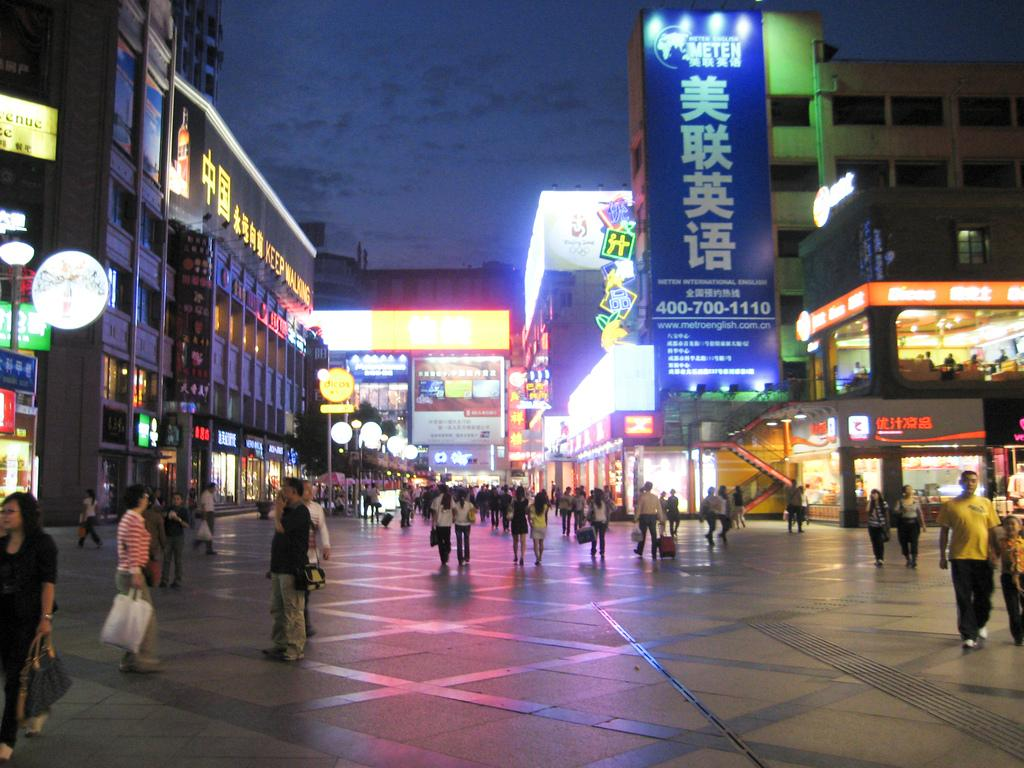What type of structures can be seen in the image? There are buildings in the image. What objects are present in the image besides the buildings? There are boards and a road visible in the image. What is the source of illumination in the image? There is light in the image. How many people are present in the image? There are many people in the image. What is visible at the top of the image? The sky is visible at the top of the image. Where is the giraffe located in the image? There is no giraffe present in the image. What type of room is visible in the image? There is no room visible in the image; it features buildings, boards, a road, and many people. 